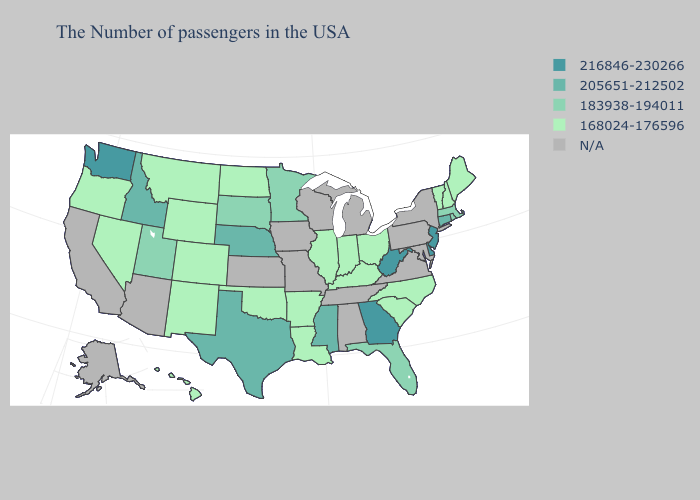Among the states that border Rhode Island , does Massachusetts have the highest value?
Short answer required. No. Which states hav the highest value in the South?
Keep it brief. Delaware, West Virginia, Georgia. Does Georgia have the highest value in the South?
Short answer required. Yes. Among the states that border California , which have the lowest value?
Be succinct. Nevada, Oregon. Which states have the lowest value in the USA?
Answer briefly. Maine, New Hampshire, Vermont, North Carolina, South Carolina, Ohio, Kentucky, Indiana, Illinois, Louisiana, Arkansas, Oklahoma, North Dakota, Wyoming, Colorado, New Mexico, Montana, Nevada, Oregon, Hawaii. Name the states that have a value in the range 216846-230266?
Write a very short answer. New Jersey, Delaware, West Virginia, Georgia, Washington. What is the lowest value in the West?
Write a very short answer. 168024-176596. Does Louisiana have the lowest value in the South?
Quick response, please. Yes. What is the lowest value in states that border Louisiana?
Concise answer only. 168024-176596. Among the states that border Arizona , which have the lowest value?
Write a very short answer. Colorado, New Mexico, Nevada. Among the states that border Illinois , which have the lowest value?
Answer briefly. Kentucky, Indiana. Name the states that have a value in the range N/A?
Give a very brief answer. New York, Maryland, Pennsylvania, Virginia, Michigan, Alabama, Tennessee, Wisconsin, Missouri, Iowa, Kansas, Arizona, California, Alaska. What is the value of Kansas?
Answer briefly. N/A. What is the highest value in the West ?
Quick response, please. 216846-230266. What is the lowest value in the South?
Quick response, please. 168024-176596. 